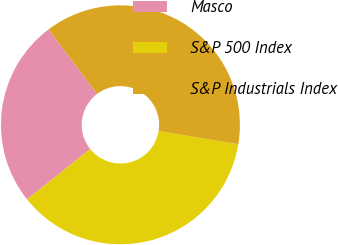Convert chart to OTSL. <chart><loc_0><loc_0><loc_500><loc_500><pie_chart><fcel>Masco<fcel>S&P 500 Index<fcel>S&P Industrials Index<nl><fcel>25.45%<fcel>36.67%<fcel>37.88%<nl></chart> 